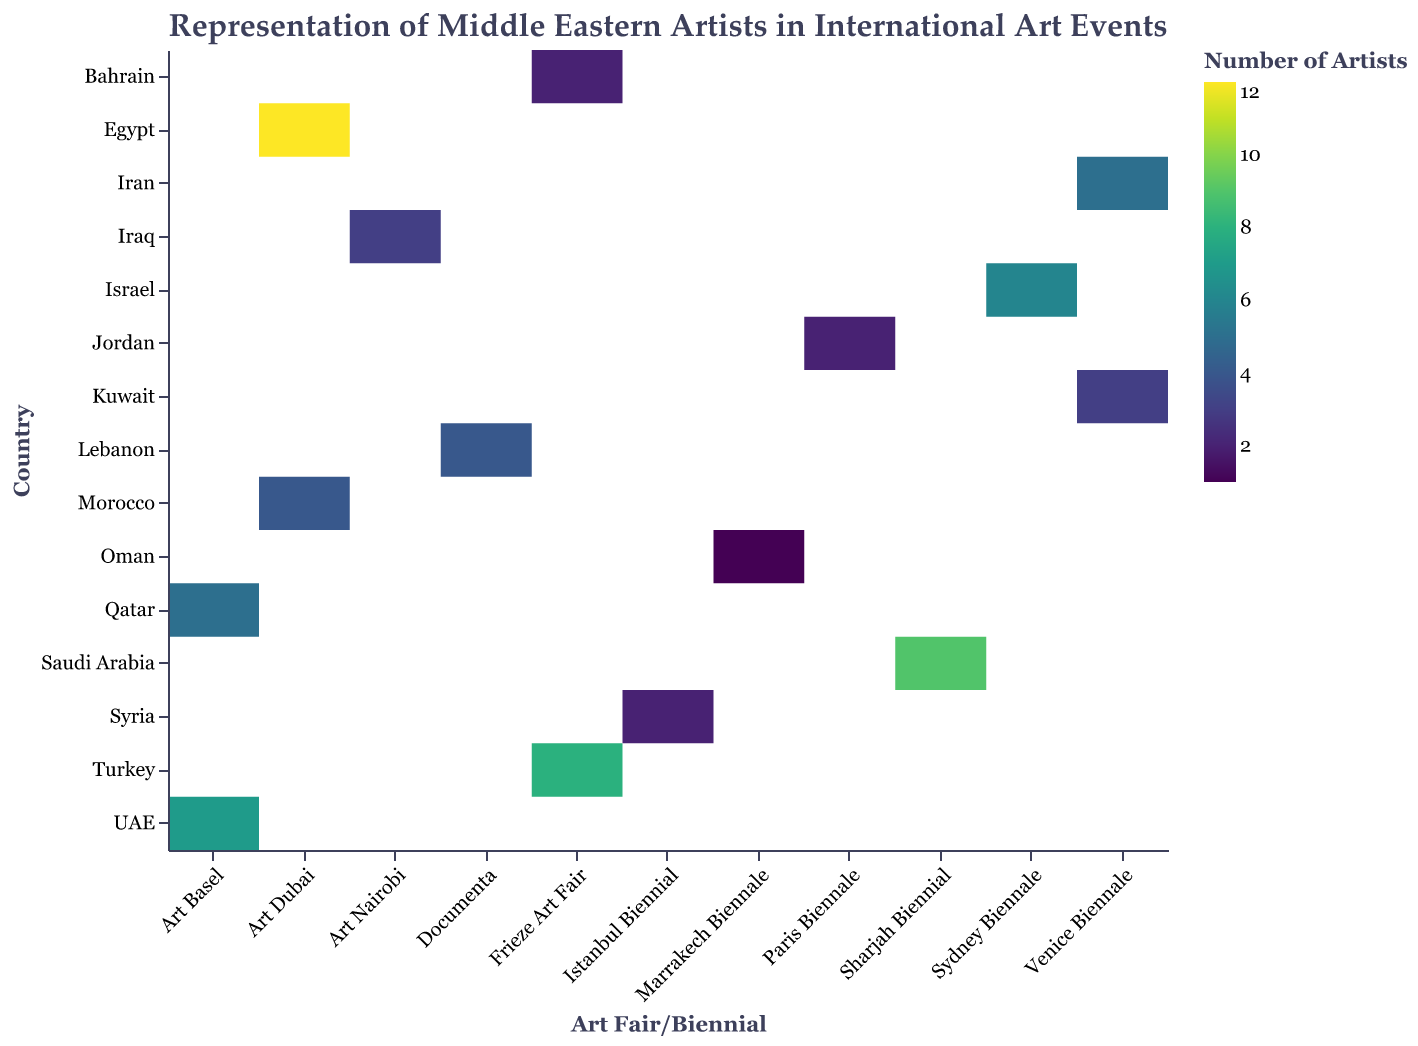What is the title of the heatmap? The title is located at the top of the heatmap and reads: "Representation of Middle Eastern Artists in International Art Events".
Answer: Representation of Middle Eastern Artists in International Art Events Which country had the highest number of artists represented at the Art Dubai fair in 2023? Look for the row corresponding to the Art Dubai fair in 2023 and identify the country with the darkest color, which represents the highest value.
Answer: Egypt How many artists from Saudi Arabia were represented at the Sharjah Biennial in 2023? Locate the row for Saudi Arabia and the column for Sharjah Biennial in 2023. Read the number directly or identify the shade of color corresponding to that cell.
Answer: 9 Compare the number of artists from Turkey at Frieze Art Fair in 2022 with those from Bahrain at Frieze Art Fair in 2023. Which has more? Look at the cells corresponding to Turkey at Frieze Art Fair in 2022 and Bahrain at Frieze Art Fair in 2023. Compare their values.
Answer: Turkey Which countries participated in the Venice Biennale in 2022, and how many artists did they present? Identify the row for Venice Biennale in 2022 and list the countries along with their respective number of artists.
Answer: Iran (5), Kuwait (3) Which country had the fewest artists represented at any international art event and how many? Look for the cell with the lightest color (representing the lowest value) and identify the country and the number.
Answer: Oman (1) Is there any country that participated in more than one art fair/biennial in the data? Check each row for duplicate country names and list any countries appearing more than once.
Answer: None 